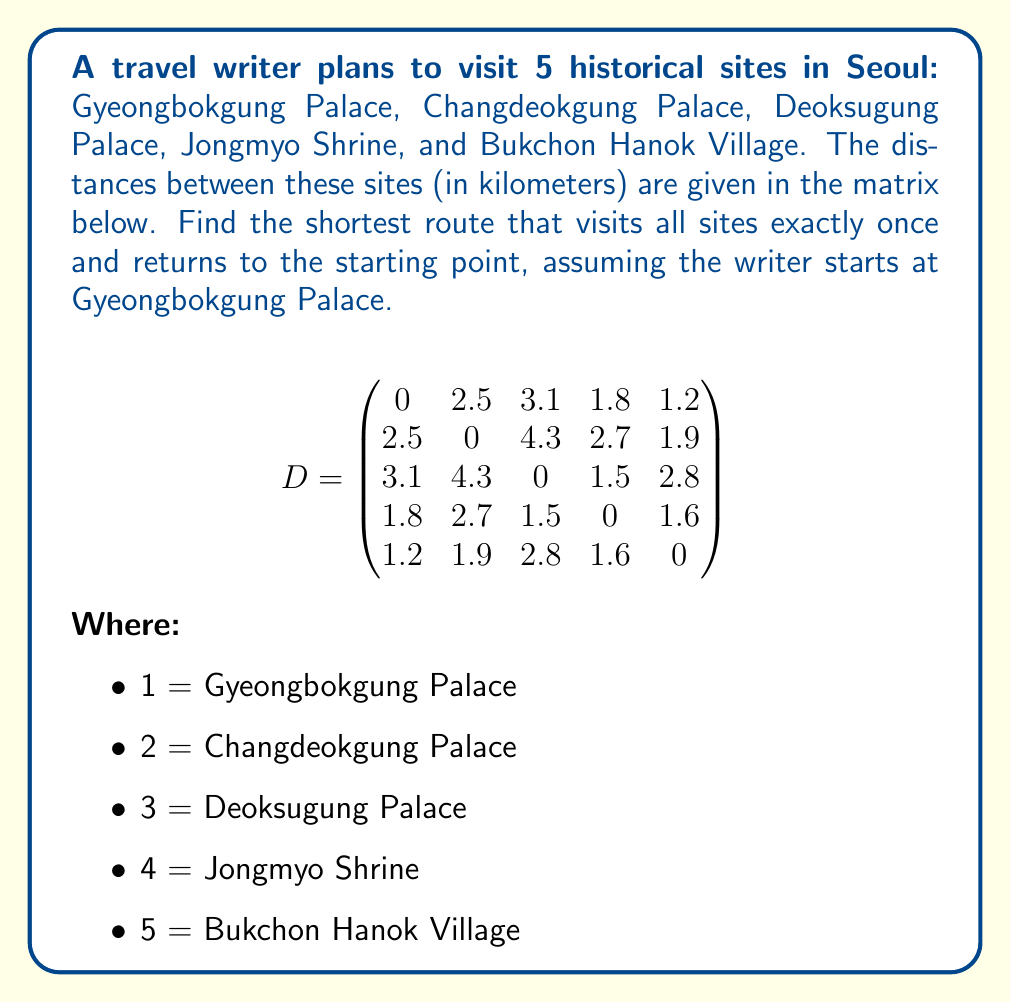Can you answer this question? This problem is an instance of the Traveling Salesman Problem (TSP). To solve it, we'll use the following steps:

1) List all possible routes starting and ending at Gyeongbokgung Palace (1):
   There are (5-1)! = 24 possible routes.

2) Calculate the total distance for each route:
   For example, route 1-2-3-4-5-1:
   $d_{12} + d_{23} + d_{34} + d_{45} + d_{51} = 2.5 + 4.3 + 1.5 + 1.6 + 1.2 = 11.1$ km

3) Compare all routes to find the shortest:
   After calculating all routes, we find the shortest is 1-5-2-4-3-1:
   
   $d_{15} + d_{52} + d_{24} + d_{43} + d_{31} = 1.2 + 1.9 + 2.7 + 1.5 + 3.1 = 10.4$ km

This route can be visualized as:

[asy]
unitsize(30);
pair[] points = {(0,0), (1,2), (3,1), (2,-1), (1,-1)};
string[] labels = {"1", "2", "3", "4", "5"};
for(int i=0; i<5; ++i) {
  dot(points[i]);
  label(labels[i], points[i], E);
}
draw(points[0]--points[4]--points[1]--points[3]--points[2]--cycle, arrow=Arrow());
[/asy]

Therefore, the optimal route for the travel writer is:
Gyeongbokgung Palace → Bukchon Hanok Village → Changdeokgung Palace → Jongmyo Shrine → Deoksugung Palace → Gyeongbokgung Palace
Answer: 1-5-2-4-3-1, 10.4 km 